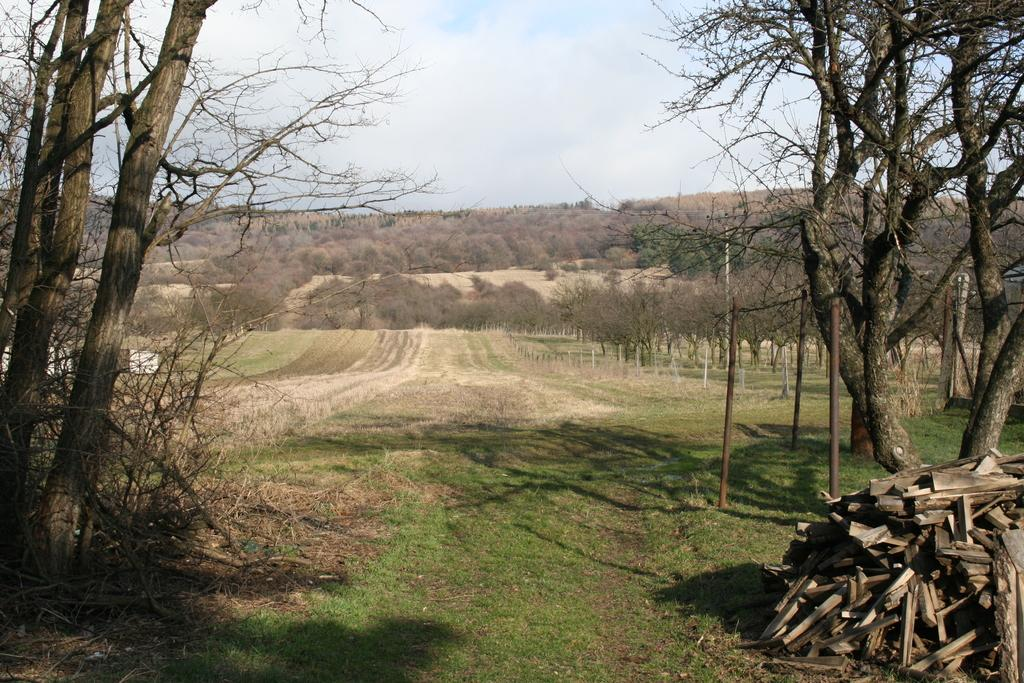What type of vegetation can be seen in the image? There are trees in the image. What type of ground cover is present in the image? There is grass in the image. What structures are visible in the image? There are poles in the image. What is the surface on which the trees and grass are growing? The ground is visible in the image. What type of material is used for the objects in the image? There are wooden objects in the image. What can be seen in the background of the image? The sky is visible in the background of the image. What type of fiction is being read by the trees in the image? There is no fiction or reading activity present in the image; it features trees, grass, poles, ground, wooden objects, and the sky. What color is the sheet draped over the wooden objects in the image? There is no sheet present in the image; it only features trees, grass, poles, ground, wooden objects, and the sky. 